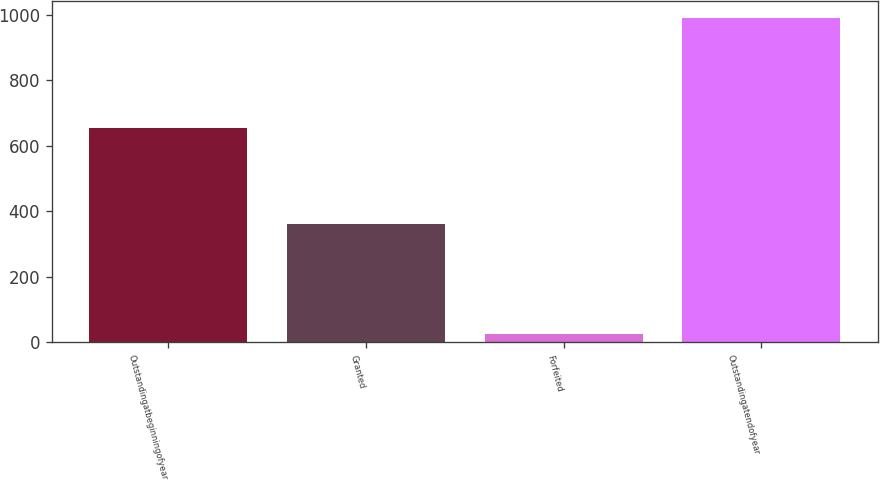Convert chart to OTSL. <chart><loc_0><loc_0><loc_500><loc_500><bar_chart><fcel>Outstandingatbeginningofyear<fcel>Granted<fcel>Forfeited<fcel>Outstandingatendofyear<nl><fcel>655<fcel>362<fcel>25<fcel>992<nl></chart> 